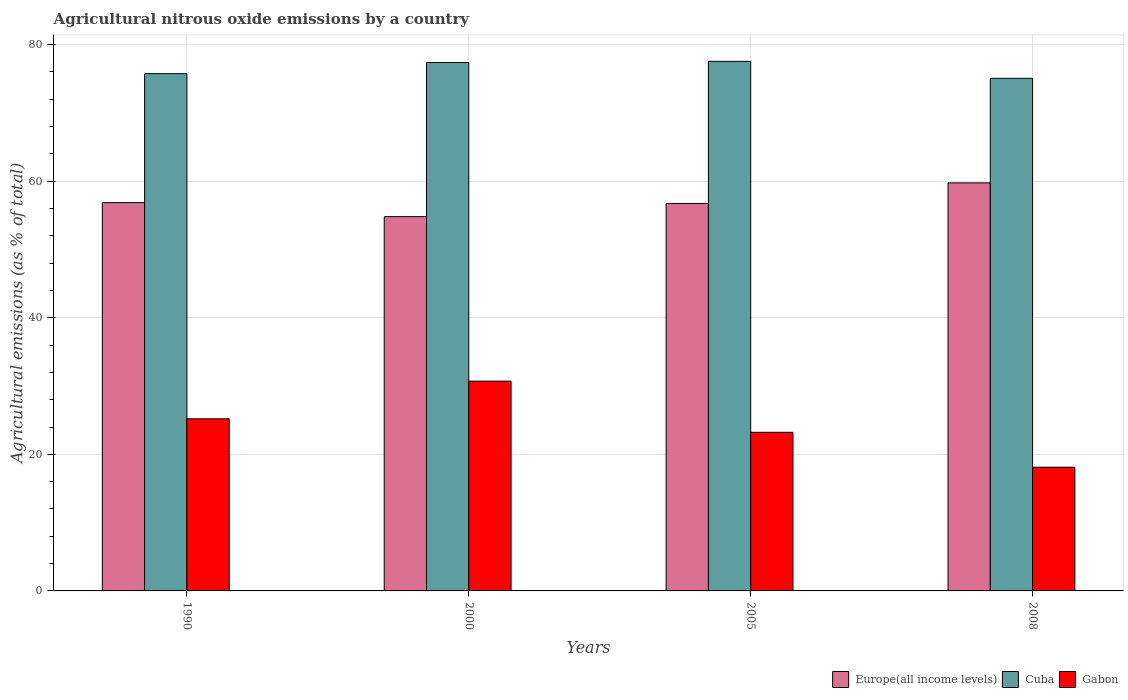How many different coloured bars are there?
Your response must be concise. 3. Are the number of bars per tick equal to the number of legend labels?
Your answer should be compact. Yes. Are the number of bars on each tick of the X-axis equal?
Make the answer very short. Yes. How many bars are there on the 1st tick from the left?
Make the answer very short. 3. How many bars are there on the 4th tick from the right?
Make the answer very short. 3. What is the amount of agricultural nitrous oxide emitted in Gabon in 1990?
Provide a succinct answer. 25.2. Across all years, what is the maximum amount of agricultural nitrous oxide emitted in Cuba?
Your answer should be compact. 77.54. Across all years, what is the minimum amount of agricultural nitrous oxide emitted in Europe(all income levels)?
Make the answer very short. 54.8. What is the total amount of agricultural nitrous oxide emitted in Europe(all income levels) in the graph?
Your response must be concise. 228.14. What is the difference between the amount of agricultural nitrous oxide emitted in Gabon in 1990 and that in 2008?
Make the answer very short. 7.09. What is the difference between the amount of agricultural nitrous oxide emitted in Cuba in 2005 and the amount of agricultural nitrous oxide emitted in Gabon in 1990?
Ensure brevity in your answer.  52.34. What is the average amount of agricultural nitrous oxide emitted in Gabon per year?
Give a very brief answer. 24.32. In the year 1990, what is the difference between the amount of agricultural nitrous oxide emitted in Cuba and amount of agricultural nitrous oxide emitted in Europe(all income levels)?
Give a very brief answer. 18.89. In how many years, is the amount of agricultural nitrous oxide emitted in Europe(all income levels) greater than 76 %?
Your answer should be compact. 0. What is the ratio of the amount of agricultural nitrous oxide emitted in Cuba in 2000 to that in 2005?
Offer a terse response. 1. Is the amount of agricultural nitrous oxide emitted in Gabon in 2000 less than that in 2005?
Provide a short and direct response. No. Is the difference between the amount of agricultural nitrous oxide emitted in Cuba in 1990 and 2008 greater than the difference between the amount of agricultural nitrous oxide emitted in Europe(all income levels) in 1990 and 2008?
Your answer should be very brief. Yes. What is the difference between the highest and the second highest amount of agricultural nitrous oxide emitted in Gabon?
Provide a short and direct response. 5.51. What is the difference between the highest and the lowest amount of agricultural nitrous oxide emitted in Europe(all income levels)?
Give a very brief answer. 4.94. What does the 3rd bar from the left in 2008 represents?
Keep it short and to the point. Gabon. What does the 1st bar from the right in 2008 represents?
Offer a terse response. Gabon. Is it the case that in every year, the sum of the amount of agricultural nitrous oxide emitted in Europe(all income levels) and amount of agricultural nitrous oxide emitted in Cuba is greater than the amount of agricultural nitrous oxide emitted in Gabon?
Your answer should be compact. Yes. How many bars are there?
Keep it short and to the point. 12. Are all the bars in the graph horizontal?
Keep it short and to the point. No. What is the title of the graph?
Provide a succinct answer. Agricultural nitrous oxide emissions by a country. What is the label or title of the Y-axis?
Ensure brevity in your answer.  Agricultural emissions (as % of total). What is the Agricultural emissions (as % of total) in Europe(all income levels) in 1990?
Make the answer very short. 56.85. What is the Agricultural emissions (as % of total) in Cuba in 1990?
Make the answer very short. 75.74. What is the Agricultural emissions (as % of total) of Gabon in 1990?
Make the answer very short. 25.2. What is the Agricultural emissions (as % of total) of Europe(all income levels) in 2000?
Your answer should be very brief. 54.8. What is the Agricultural emissions (as % of total) of Cuba in 2000?
Provide a succinct answer. 77.37. What is the Agricultural emissions (as % of total) of Gabon in 2000?
Make the answer very short. 30.72. What is the Agricultural emissions (as % of total) in Europe(all income levels) in 2005?
Your answer should be very brief. 56.74. What is the Agricultural emissions (as % of total) of Cuba in 2005?
Provide a succinct answer. 77.54. What is the Agricultural emissions (as % of total) of Gabon in 2005?
Provide a short and direct response. 23.22. What is the Agricultural emissions (as % of total) in Europe(all income levels) in 2008?
Provide a succinct answer. 59.75. What is the Agricultural emissions (as % of total) of Cuba in 2008?
Your answer should be compact. 75.06. What is the Agricultural emissions (as % of total) in Gabon in 2008?
Your response must be concise. 18.12. Across all years, what is the maximum Agricultural emissions (as % of total) in Europe(all income levels)?
Your response must be concise. 59.75. Across all years, what is the maximum Agricultural emissions (as % of total) in Cuba?
Give a very brief answer. 77.54. Across all years, what is the maximum Agricultural emissions (as % of total) in Gabon?
Keep it short and to the point. 30.72. Across all years, what is the minimum Agricultural emissions (as % of total) in Europe(all income levels)?
Your answer should be very brief. 54.8. Across all years, what is the minimum Agricultural emissions (as % of total) of Cuba?
Offer a very short reply. 75.06. Across all years, what is the minimum Agricultural emissions (as % of total) of Gabon?
Offer a very short reply. 18.12. What is the total Agricultural emissions (as % of total) in Europe(all income levels) in the graph?
Your answer should be very brief. 228.14. What is the total Agricultural emissions (as % of total) in Cuba in the graph?
Make the answer very short. 305.72. What is the total Agricultural emissions (as % of total) of Gabon in the graph?
Keep it short and to the point. 97.26. What is the difference between the Agricultural emissions (as % of total) of Europe(all income levels) in 1990 and that in 2000?
Offer a terse response. 2.05. What is the difference between the Agricultural emissions (as % of total) of Cuba in 1990 and that in 2000?
Ensure brevity in your answer.  -1.63. What is the difference between the Agricultural emissions (as % of total) in Gabon in 1990 and that in 2000?
Offer a very short reply. -5.51. What is the difference between the Agricultural emissions (as % of total) of Europe(all income levels) in 1990 and that in 2005?
Ensure brevity in your answer.  0.12. What is the difference between the Agricultural emissions (as % of total) of Cuba in 1990 and that in 2005?
Your response must be concise. -1.8. What is the difference between the Agricultural emissions (as % of total) of Gabon in 1990 and that in 2005?
Make the answer very short. 1.98. What is the difference between the Agricultural emissions (as % of total) in Europe(all income levels) in 1990 and that in 2008?
Provide a short and direct response. -2.89. What is the difference between the Agricultural emissions (as % of total) in Cuba in 1990 and that in 2008?
Offer a terse response. 0.68. What is the difference between the Agricultural emissions (as % of total) of Gabon in 1990 and that in 2008?
Your response must be concise. 7.09. What is the difference between the Agricultural emissions (as % of total) in Europe(all income levels) in 2000 and that in 2005?
Keep it short and to the point. -1.93. What is the difference between the Agricultural emissions (as % of total) in Cuba in 2000 and that in 2005?
Your response must be concise. -0.17. What is the difference between the Agricultural emissions (as % of total) in Gabon in 2000 and that in 2005?
Your answer should be compact. 7.49. What is the difference between the Agricultural emissions (as % of total) of Europe(all income levels) in 2000 and that in 2008?
Keep it short and to the point. -4.94. What is the difference between the Agricultural emissions (as % of total) in Cuba in 2000 and that in 2008?
Provide a succinct answer. 2.31. What is the difference between the Agricultural emissions (as % of total) in Gabon in 2000 and that in 2008?
Your answer should be compact. 12.6. What is the difference between the Agricultural emissions (as % of total) of Europe(all income levels) in 2005 and that in 2008?
Make the answer very short. -3.01. What is the difference between the Agricultural emissions (as % of total) of Cuba in 2005 and that in 2008?
Keep it short and to the point. 2.48. What is the difference between the Agricultural emissions (as % of total) in Gabon in 2005 and that in 2008?
Keep it short and to the point. 5.11. What is the difference between the Agricultural emissions (as % of total) in Europe(all income levels) in 1990 and the Agricultural emissions (as % of total) in Cuba in 2000?
Offer a very short reply. -20.52. What is the difference between the Agricultural emissions (as % of total) in Europe(all income levels) in 1990 and the Agricultural emissions (as % of total) in Gabon in 2000?
Offer a very short reply. 26.14. What is the difference between the Agricultural emissions (as % of total) of Cuba in 1990 and the Agricultural emissions (as % of total) of Gabon in 2000?
Your answer should be compact. 45.02. What is the difference between the Agricultural emissions (as % of total) of Europe(all income levels) in 1990 and the Agricultural emissions (as % of total) of Cuba in 2005?
Your answer should be compact. -20.69. What is the difference between the Agricultural emissions (as % of total) of Europe(all income levels) in 1990 and the Agricultural emissions (as % of total) of Gabon in 2005?
Provide a short and direct response. 33.63. What is the difference between the Agricultural emissions (as % of total) of Cuba in 1990 and the Agricultural emissions (as % of total) of Gabon in 2005?
Provide a short and direct response. 52.52. What is the difference between the Agricultural emissions (as % of total) of Europe(all income levels) in 1990 and the Agricultural emissions (as % of total) of Cuba in 2008?
Provide a succinct answer. -18.2. What is the difference between the Agricultural emissions (as % of total) of Europe(all income levels) in 1990 and the Agricultural emissions (as % of total) of Gabon in 2008?
Your response must be concise. 38.74. What is the difference between the Agricultural emissions (as % of total) in Cuba in 1990 and the Agricultural emissions (as % of total) in Gabon in 2008?
Your answer should be compact. 57.63. What is the difference between the Agricultural emissions (as % of total) in Europe(all income levels) in 2000 and the Agricultural emissions (as % of total) in Cuba in 2005?
Provide a short and direct response. -22.74. What is the difference between the Agricultural emissions (as % of total) in Europe(all income levels) in 2000 and the Agricultural emissions (as % of total) in Gabon in 2005?
Make the answer very short. 31.58. What is the difference between the Agricultural emissions (as % of total) of Cuba in 2000 and the Agricultural emissions (as % of total) of Gabon in 2005?
Make the answer very short. 54.15. What is the difference between the Agricultural emissions (as % of total) of Europe(all income levels) in 2000 and the Agricultural emissions (as % of total) of Cuba in 2008?
Keep it short and to the point. -20.26. What is the difference between the Agricultural emissions (as % of total) in Europe(all income levels) in 2000 and the Agricultural emissions (as % of total) in Gabon in 2008?
Your answer should be compact. 36.69. What is the difference between the Agricultural emissions (as % of total) of Cuba in 2000 and the Agricultural emissions (as % of total) of Gabon in 2008?
Give a very brief answer. 59.26. What is the difference between the Agricultural emissions (as % of total) of Europe(all income levels) in 2005 and the Agricultural emissions (as % of total) of Cuba in 2008?
Your response must be concise. -18.32. What is the difference between the Agricultural emissions (as % of total) in Europe(all income levels) in 2005 and the Agricultural emissions (as % of total) in Gabon in 2008?
Ensure brevity in your answer.  38.62. What is the difference between the Agricultural emissions (as % of total) of Cuba in 2005 and the Agricultural emissions (as % of total) of Gabon in 2008?
Offer a terse response. 59.43. What is the average Agricultural emissions (as % of total) of Europe(all income levels) per year?
Your answer should be compact. 57.04. What is the average Agricultural emissions (as % of total) of Cuba per year?
Provide a short and direct response. 76.43. What is the average Agricultural emissions (as % of total) in Gabon per year?
Keep it short and to the point. 24.32. In the year 1990, what is the difference between the Agricultural emissions (as % of total) in Europe(all income levels) and Agricultural emissions (as % of total) in Cuba?
Your answer should be compact. -18.89. In the year 1990, what is the difference between the Agricultural emissions (as % of total) in Europe(all income levels) and Agricultural emissions (as % of total) in Gabon?
Provide a succinct answer. 31.65. In the year 1990, what is the difference between the Agricultural emissions (as % of total) in Cuba and Agricultural emissions (as % of total) in Gabon?
Provide a succinct answer. 50.54. In the year 2000, what is the difference between the Agricultural emissions (as % of total) in Europe(all income levels) and Agricultural emissions (as % of total) in Cuba?
Offer a very short reply. -22.57. In the year 2000, what is the difference between the Agricultural emissions (as % of total) of Europe(all income levels) and Agricultural emissions (as % of total) of Gabon?
Your answer should be very brief. 24.09. In the year 2000, what is the difference between the Agricultural emissions (as % of total) in Cuba and Agricultural emissions (as % of total) in Gabon?
Make the answer very short. 46.65. In the year 2005, what is the difference between the Agricultural emissions (as % of total) of Europe(all income levels) and Agricultural emissions (as % of total) of Cuba?
Provide a short and direct response. -20.81. In the year 2005, what is the difference between the Agricultural emissions (as % of total) of Europe(all income levels) and Agricultural emissions (as % of total) of Gabon?
Make the answer very short. 33.51. In the year 2005, what is the difference between the Agricultural emissions (as % of total) of Cuba and Agricultural emissions (as % of total) of Gabon?
Your answer should be very brief. 54.32. In the year 2008, what is the difference between the Agricultural emissions (as % of total) in Europe(all income levels) and Agricultural emissions (as % of total) in Cuba?
Ensure brevity in your answer.  -15.31. In the year 2008, what is the difference between the Agricultural emissions (as % of total) of Europe(all income levels) and Agricultural emissions (as % of total) of Gabon?
Your answer should be compact. 41.63. In the year 2008, what is the difference between the Agricultural emissions (as % of total) of Cuba and Agricultural emissions (as % of total) of Gabon?
Offer a terse response. 56.94. What is the ratio of the Agricultural emissions (as % of total) in Europe(all income levels) in 1990 to that in 2000?
Make the answer very short. 1.04. What is the ratio of the Agricultural emissions (as % of total) in Cuba in 1990 to that in 2000?
Your response must be concise. 0.98. What is the ratio of the Agricultural emissions (as % of total) in Gabon in 1990 to that in 2000?
Keep it short and to the point. 0.82. What is the ratio of the Agricultural emissions (as % of total) in Cuba in 1990 to that in 2005?
Your response must be concise. 0.98. What is the ratio of the Agricultural emissions (as % of total) in Gabon in 1990 to that in 2005?
Your response must be concise. 1.09. What is the ratio of the Agricultural emissions (as % of total) of Europe(all income levels) in 1990 to that in 2008?
Offer a terse response. 0.95. What is the ratio of the Agricultural emissions (as % of total) of Cuba in 1990 to that in 2008?
Provide a short and direct response. 1.01. What is the ratio of the Agricultural emissions (as % of total) in Gabon in 1990 to that in 2008?
Your answer should be very brief. 1.39. What is the ratio of the Agricultural emissions (as % of total) in Europe(all income levels) in 2000 to that in 2005?
Offer a very short reply. 0.97. What is the ratio of the Agricultural emissions (as % of total) in Cuba in 2000 to that in 2005?
Make the answer very short. 1. What is the ratio of the Agricultural emissions (as % of total) in Gabon in 2000 to that in 2005?
Provide a succinct answer. 1.32. What is the ratio of the Agricultural emissions (as % of total) of Europe(all income levels) in 2000 to that in 2008?
Ensure brevity in your answer.  0.92. What is the ratio of the Agricultural emissions (as % of total) of Cuba in 2000 to that in 2008?
Keep it short and to the point. 1.03. What is the ratio of the Agricultural emissions (as % of total) of Gabon in 2000 to that in 2008?
Your answer should be compact. 1.7. What is the ratio of the Agricultural emissions (as % of total) of Europe(all income levels) in 2005 to that in 2008?
Offer a terse response. 0.95. What is the ratio of the Agricultural emissions (as % of total) of Cuba in 2005 to that in 2008?
Your response must be concise. 1.03. What is the ratio of the Agricultural emissions (as % of total) of Gabon in 2005 to that in 2008?
Provide a succinct answer. 1.28. What is the difference between the highest and the second highest Agricultural emissions (as % of total) in Europe(all income levels)?
Keep it short and to the point. 2.89. What is the difference between the highest and the second highest Agricultural emissions (as % of total) of Cuba?
Keep it short and to the point. 0.17. What is the difference between the highest and the second highest Agricultural emissions (as % of total) of Gabon?
Your response must be concise. 5.51. What is the difference between the highest and the lowest Agricultural emissions (as % of total) in Europe(all income levels)?
Give a very brief answer. 4.94. What is the difference between the highest and the lowest Agricultural emissions (as % of total) in Cuba?
Offer a very short reply. 2.48. What is the difference between the highest and the lowest Agricultural emissions (as % of total) of Gabon?
Give a very brief answer. 12.6. 